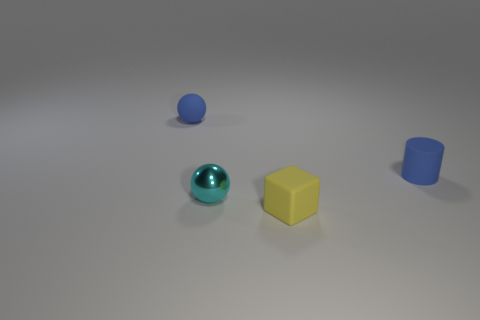Add 4 small blue matte cylinders. How many objects exist? 8 Subtract all blocks. How many objects are left? 3 Add 4 blue rubber things. How many blue rubber things are left? 6 Add 1 blue cylinders. How many blue cylinders exist? 2 Subtract 0 green cylinders. How many objects are left? 4 Subtract all gray balls. Subtract all green cubes. How many balls are left? 2 Subtract all small rubber cylinders. Subtract all tiny cyan objects. How many objects are left? 2 